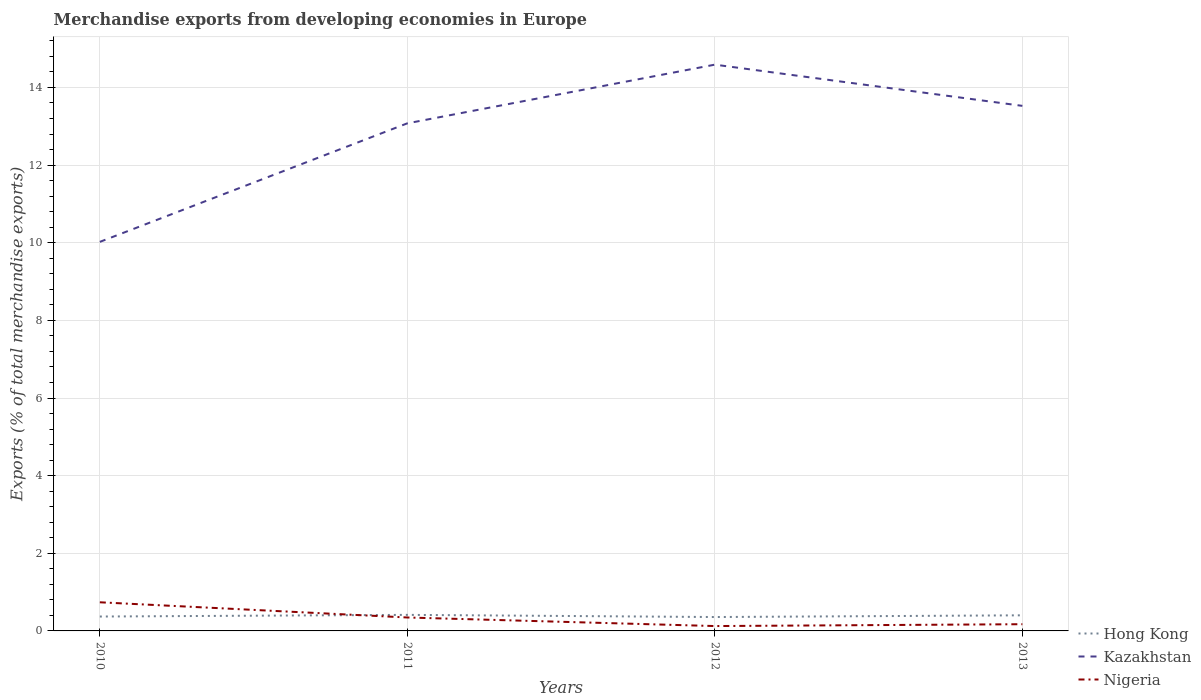How many different coloured lines are there?
Provide a succinct answer. 3. Does the line corresponding to Hong Kong intersect with the line corresponding to Kazakhstan?
Provide a succinct answer. No. Across all years, what is the maximum percentage of total merchandise exports in Nigeria?
Offer a terse response. 0.13. What is the total percentage of total merchandise exports in Kazakhstan in the graph?
Keep it short and to the point. -3.05. What is the difference between the highest and the second highest percentage of total merchandise exports in Kazakhstan?
Your answer should be very brief. 4.57. Is the percentage of total merchandise exports in Nigeria strictly greater than the percentage of total merchandise exports in Hong Kong over the years?
Provide a succinct answer. No. How many lines are there?
Make the answer very short. 3. What is the difference between two consecutive major ticks on the Y-axis?
Give a very brief answer. 2. Are the values on the major ticks of Y-axis written in scientific E-notation?
Provide a short and direct response. No. Does the graph contain any zero values?
Your answer should be compact. No. How are the legend labels stacked?
Provide a succinct answer. Vertical. What is the title of the graph?
Ensure brevity in your answer.  Merchandise exports from developing economies in Europe. What is the label or title of the Y-axis?
Offer a very short reply. Exports (% of total merchandise exports). What is the Exports (% of total merchandise exports) of Hong Kong in 2010?
Your answer should be very brief. 0.37. What is the Exports (% of total merchandise exports) of Kazakhstan in 2010?
Provide a short and direct response. 10.02. What is the Exports (% of total merchandise exports) of Nigeria in 2010?
Provide a succinct answer. 0.74. What is the Exports (% of total merchandise exports) of Hong Kong in 2011?
Provide a succinct answer. 0.41. What is the Exports (% of total merchandise exports) in Kazakhstan in 2011?
Keep it short and to the point. 13.08. What is the Exports (% of total merchandise exports) in Nigeria in 2011?
Your answer should be very brief. 0.35. What is the Exports (% of total merchandise exports) of Hong Kong in 2012?
Make the answer very short. 0.36. What is the Exports (% of total merchandise exports) in Kazakhstan in 2012?
Your response must be concise. 14.59. What is the Exports (% of total merchandise exports) in Nigeria in 2012?
Provide a succinct answer. 0.13. What is the Exports (% of total merchandise exports) of Hong Kong in 2013?
Keep it short and to the point. 0.4. What is the Exports (% of total merchandise exports) of Kazakhstan in 2013?
Offer a terse response. 13.53. What is the Exports (% of total merchandise exports) in Nigeria in 2013?
Provide a succinct answer. 0.17. Across all years, what is the maximum Exports (% of total merchandise exports) of Hong Kong?
Your answer should be very brief. 0.41. Across all years, what is the maximum Exports (% of total merchandise exports) of Kazakhstan?
Offer a terse response. 14.59. Across all years, what is the maximum Exports (% of total merchandise exports) in Nigeria?
Offer a terse response. 0.74. Across all years, what is the minimum Exports (% of total merchandise exports) of Hong Kong?
Your response must be concise. 0.36. Across all years, what is the minimum Exports (% of total merchandise exports) in Kazakhstan?
Your answer should be very brief. 10.02. Across all years, what is the minimum Exports (% of total merchandise exports) of Nigeria?
Your answer should be very brief. 0.13. What is the total Exports (% of total merchandise exports) of Hong Kong in the graph?
Your response must be concise. 1.54. What is the total Exports (% of total merchandise exports) in Kazakhstan in the graph?
Provide a succinct answer. 51.21. What is the total Exports (% of total merchandise exports) in Nigeria in the graph?
Provide a short and direct response. 1.38. What is the difference between the Exports (% of total merchandise exports) of Hong Kong in 2010 and that in 2011?
Give a very brief answer. -0.04. What is the difference between the Exports (% of total merchandise exports) of Kazakhstan in 2010 and that in 2011?
Offer a very short reply. -3.05. What is the difference between the Exports (% of total merchandise exports) in Nigeria in 2010 and that in 2011?
Your response must be concise. 0.39. What is the difference between the Exports (% of total merchandise exports) in Hong Kong in 2010 and that in 2012?
Your answer should be compact. 0.01. What is the difference between the Exports (% of total merchandise exports) of Kazakhstan in 2010 and that in 2012?
Your answer should be very brief. -4.57. What is the difference between the Exports (% of total merchandise exports) in Nigeria in 2010 and that in 2012?
Provide a short and direct response. 0.61. What is the difference between the Exports (% of total merchandise exports) in Hong Kong in 2010 and that in 2013?
Keep it short and to the point. -0.03. What is the difference between the Exports (% of total merchandise exports) in Kazakhstan in 2010 and that in 2013?
Keep it short and to the point. -3.5. What is the difference between the Exports (% of total merchandise exports) in Nigeria in 2010 and that in 2013?
Give a very brief answer. 0.56. What is the difference between the Exports (% of total merchandise exports) of Hong Kong in 2011 and that in 2012?
Keep it short and to the point. 0.06. What is the difference between the Exports (% of total merchandise exports) in Kazakhstan in 2011 and that in 2012?
Your response must be concise. -1.51. What is the difference between the Exports (% of total merchandise exports) in Nigeria in 2011 and that in 2012?
Offer a terse response. 0.22. What is the difference between the Exports (% of total merchandise exports) of Hong Kong in 2011 and that in 2013?
Provide a succinct answer. 0.01. What is the difference between the Exports (% of total merchandise exports) of Kazakhstan in 2011 and that in 2013?
Your answer should be very brief. -0.45. What is the difference between the Exports (% of total merchandise exports) in Nigeria in 2011 and that in 2013?
Offer a very short reply. 0.17. What is the difference between the Exports (% of total merchandise exports) of Hong Kong in 2012 and that in 2013?
Keep it short and to the point. -0.04. What is the difference between the Exports (% of total merchandise exports) in Kazakhstan in 2012 and that in 2013?
Offer a terse response. 1.06. What is the difference between the Exports (% of total merchandise exports) in Nigeria in 2012 and that in 2013?
Your answer should be compact. -0.05. What is the difference between the Exports (% of total merchandise exports) in Hong Kong in 2010 and the Exports (% of total merchandise exports) in Kazakhstan in 2011?
Keep it short and to the point. -12.71. What is the difference between the Exports (% of total merchandise exports) in Hong Kong in 2010 and the Exports (% of total merchandise exports) in Nigeria in 2011?
Provide a short and direct response. 0.02. What is the difference between the Exports (% of total merchandise exports) of Kazakhstan in 2010 and the Exports (% of total merchandise exports) of Nigeria in 2011?
Provide a short and direct response. 9.68. What is the difference between the Exports (% of total merchandise exports) of Hong Kong in 2010 and the Exports (% of total merchandise exports) of Kazakhstan in 2012?
Provide a succinct answer. -14.22. What is the difference between the Exports (% of total merchandise exports) of Hong Kong in 2010 and the Exports (% of total merchandise exports) of Nigeria in 2012?
Ensure brevity in your answer.  0.25. What is the difference between the Exports (% of total merchandise exports) of Kazakhstan in 2010 and the Exports (% of total merchandise exports) of Nigeria in 2012?
Ensure brevity in your answer.  9.9. What is the difference between the Exports (% of total merchandise exports) of Hong Kong in 2010 and the Exports (% of total merchandise exports) of Kazakhstan in 2013?
Your answer should be compact. -13.16. What is the difference between the Exports (% of total merchandise exports) in Hong Kong in 2010 and the Exports (% of total merchandise exports) in Nigeria in 2013?
Offer a very short reply. 0.2. What is the difference between the Exports (% of total merchandise exports) of Kazakhstan in 2010 and the Exports (% of total merchandise exports) of Nigeria in 2013?
Ensure brevity in your answer.  9.85. What is the difference between the Exports (% of total merchandise exports) of Hong Kong in 2011 and the Exports (% of total merchandise exports) of Kazakhstan in 2012?
Your answer should be compact. -14.17. What is the difference between the Exports (% of total merchandise exports) of Hong Kong in 2011 and the Exports (% of total merchandise exports) of Nigeria in 2012?
Provide a short and direct response. 0.29. What is the difference between the Exports (% of total merchandise exports) in Kazakhstan in 2011 and the Exports (% of total merchandise exports) in Nigeria in 2012?
Offer a terse response. 12.95. What is the difference between the Exports (% of total merchandise exports) of Hong Kong in 2011 and the Exports (% of total merchandise exports) of Kazakhstan in 2013?
Ensure brevity in your answer.  -13.11. What is the difference between the Exports (% of total merchandise exports) of Hong Kong in 2011 and the Exports (% of total merchandise exports) of Nigeria in 2013?
Ensure brevity in your answer.  0.24. What is the difference between the Exports (% of total merchandise exports) of Kazakhstan in 2011 and the Exports (% of total merchandise exports) of Nigeria in 2013?
Provide a short and direct response. 12.9. What is the difference between the Exports (% of total merchandise exports) in Hong Kong in 2012 and the Exports (% of total merchandise exports) in Kazakhstan in 2013?
Provide a short and direct response. -13.17. What is the difference between the Exports (% of total merchandise exports) of Hong Kong in 2012 and the Exports (% of total merchandise exports) of Nigeria in 2013?
Offer a very short reply. 0.18. What is the difference between the Exports (% of total merchandise exports) of Kazakhstan in 2012 and the Exports (% of total merchandise exports) of Nigeria in 2013?
Offer a very short reply. 14.42. What is the average Exports (% of total merchandise exports) in Hong Kong per year?
Keep it short and to the point. 0.39. What is the average Exports (% of total merchandise exports) in Kazakhstan per year?
Provide a succinct answer. 12.8. What is the average Exports (% of total merchandise exports) of Nigeria per year?
Ensure brevity in your answer.  0.35. In the year 2010, what is the difference between the Exports (% of total merchandise exports) in Hong Kong and Exports (% of total merchandise exports) in Kazakhstan?
Your response must be concise. -9.65. In the year 2010, what is the difference between the Exports (% of total merchandise exports) in Hong Kong and Exports (% of total merchandise exports) in Nigeria?
Your answer should be very brief. -0.37. In the year 2010, what is the difference between the Exports (% of total merchandise exports) in Kazakhstan and Exports (% of total merchandise exports) in Nigeria?
Your answer should be very brief. 9.28. In the year 2011, what is the difference between the Exports (% of total merchandise exports) of Hong Kong and Exports (% of total merchandise exports) of Kazakhstan?
Your answer should be very brief. -12.66. In the year 2011, what is the difference between the Exports (% of total merchandise exports) in Hong Kong and Exports (% of total merchandise exports) in Nigeria?
Offer a terse response. 0.07. In the year 2011, what is the difference between the Exports (% of total merchandise exports) in Kazakhstan and Exports (% of total merchandise exports) in Nigeria?
Make the answer very short. 12.73. In the year 2012, what is the difference between the Exports (% of total merchandise exports) in Hong Kong and Exports (% of total merchandise exports) in Kazakhstan?
Offer a very short reply. -14.23. In the year 2012, what is the difference between the Exports (% of total merchandise exports) of Hong Kong and Exports (% of total merchandise exports) of Nigeria?
Provide a succinct answer. 0.23. In the year 2012, what is the difference between the Exports (% of total merchandise exports) in Kazakhstan and Exports (% of total merchandise exports) in Nigeria?
Offer a terse response. 14.46. In the year 2013, what is the difference between the Exports (% of total merchandise exports) in Hong Kong and Exports (% of total merchandise exports) in Kazakhstan?
Give a very brief answer. -13.12. In the year 2013, what is the difference between the Exports (% of total merchandise exports) of Hong Kong and Exports (% of total merchandise exports) of Nigeria?
Your response must be concise. 0.23. In the year 2013, what is the difference between the Exports (% of total merchandise exports) of Kazakhstan and Exports (% of total merchandise exports) of Nigeria?
Your response must be concise. 13.35. What is the ratio of the Exports (% of total merchandise exports) in Hong Kong in 2010 to that in 2011?
Provide a short and direct response. 0.9. What is the ratio of the Exports (% of total merchandise exports) of Kazakhstan in 2010 to that in 2011?
Your response must be concise. 0.77. What is the ratio of the Exports (% of total merchandise exports) of Nigeria in 2010 to that in 2011?
Make the answer very short. 2.13. What is the ratio of the Exports (% of total merchandise exports) in Hong Kong in 2010 to that in 2012?
Your answer should be compact. 1.04. What is the ratio of the Exports (% of total merchandise exports) of Kazakhstan in 2010 to that in 2012?
Give a very brief answer. 0.69. What is the ratio of the Exports (% of total merchandise exports) in Nigeria in 2010 to that in 2012?
Ensure brevity in your answer.  5.89. What is the ratio of the Exports (% of total merchandise exports) of Hong Kong in 2010 to that in 2013?
Give a very brief answer. 0.92. What is the ratio of the Exports (% of total merchandise exports) of Kazakhstan in 2010 to that in 2013?
Make the answer very short. 0.74. What is the ratio of the Exports (% of total merchandise exports) in Nigeria in 2010 to that in 2013?
Your answer should be compact. 4.27. What is the ratio of the Exports (% of total merchandise exports) of Hong Kong in 2011 to that in 2012?
Provide a short and direct response. 1.16. What is the ratio of the Exports (% of total merchandise exports) of Kazakhstan in 2011 to that in 2012?
Make the answer very short. 0.9. What is the ratio of the Exports (% of total merchandise exports) of Nigeria in 2011 to that in 2012?
Offer a very short reply. 2.76. What is the ratio of the Exports (% of total merchandise exports) in Hong Kong in 2011 to that in 2013?
Keep it short and to the point. 1.03. What is the ratio of the Exports (% of total merchandise exports) of Kazakhstan in 2011 to that in 2013?
Keep it short and to the point. 0.97. What is the ratio of the Exports (% of total merchandise exports) in Nigeria in 2011 to that in 2013?
Make the answer very short. 2. What is the ratio of the Exports (% of total merchandise exports) in Hong Kong in 2012 to that in 2013?
Make the answer very short. 0.89. What is the ratio of the Exports (% of total merchandise exports) of Kazakhstan in 2012 to that in 2013?
Provide a succinct answer. 1.08. What is the ratio of the Exports (% of total merchandise exports) in Nigeria in 2012 to that in 2013?
Your answer should be very brief. 0.72. What is the difference between the highest and the second highest Exports (% of total merchandise exports) of Hong Kong?
Give a very brief answer. 0.01. What is the difference between the highest and the second highest Exports (% of total merchandise exports) in Kazakhstan?
Offer a terse response. 1.06. What is the difference between the highest and the second highest Exports (% of total merchandise exports) in Nigeria?
Offer a terse response. 0.39. What is the difference between the highest and the lowest Exports (% of total merchandise exports) in Hong Kong?
Offer a terse response. 0.06. What is the difference between the highest and the lowest Exports (% of total merchandise exports) in Kazakhstan?
Keep it short and to the point. 4.57. What is the difference between the highest and the lowest Exports (% of total merchandise exports) in Nigeria?
Offer a terse response. 0.61. 